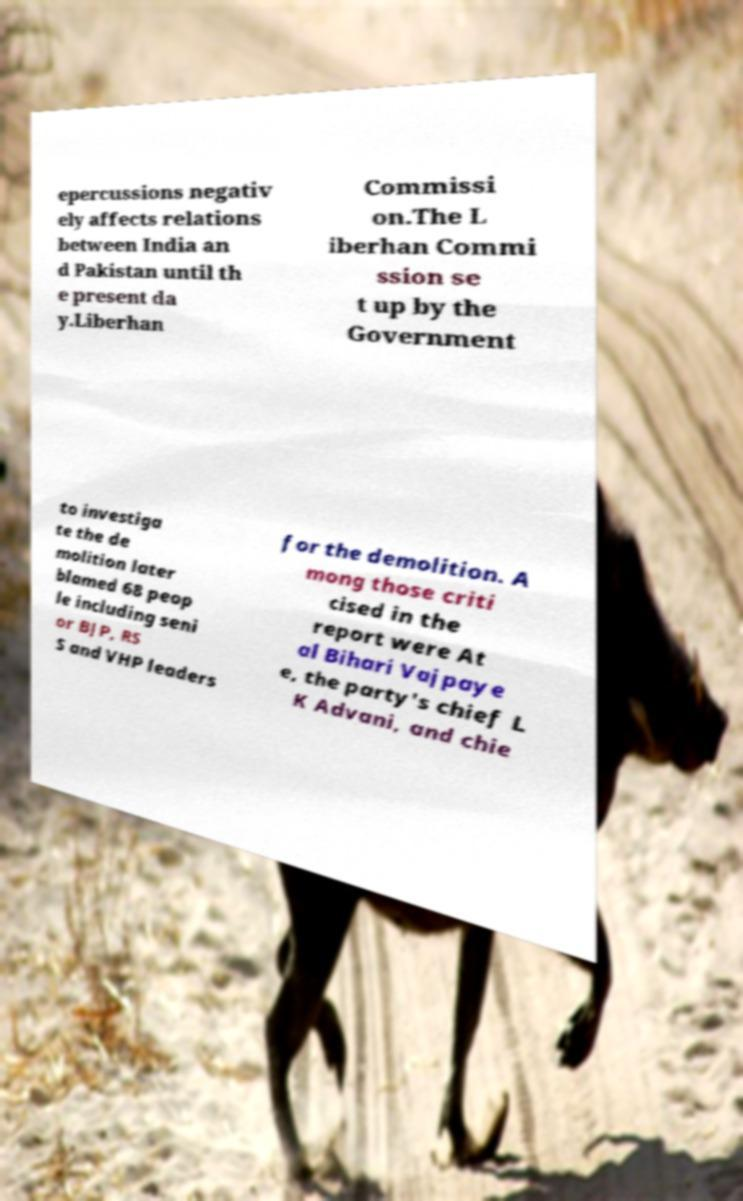What messages or text are displayed in this image? I need them in a readable, typed format. epercussions negativ ely affects relations between India an d Pakistan until th e present da y.Liberhan Commissi on.The L iberhan Commi ssion se t up by the Government to investiga te the de molition later blamed 68 peop le including seni or BJP, RS S and VHP leaders for the demolition. A mong those criti cised in the report were At al Bihari Vajpaye e, the party's chief L K Advani, and chie 